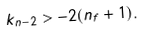<formula> <loc_0><loc_0><loc_500><loc_500>k _ { n - 2 } > - 2 ( n _ { f } + 1 ) .</formula> 